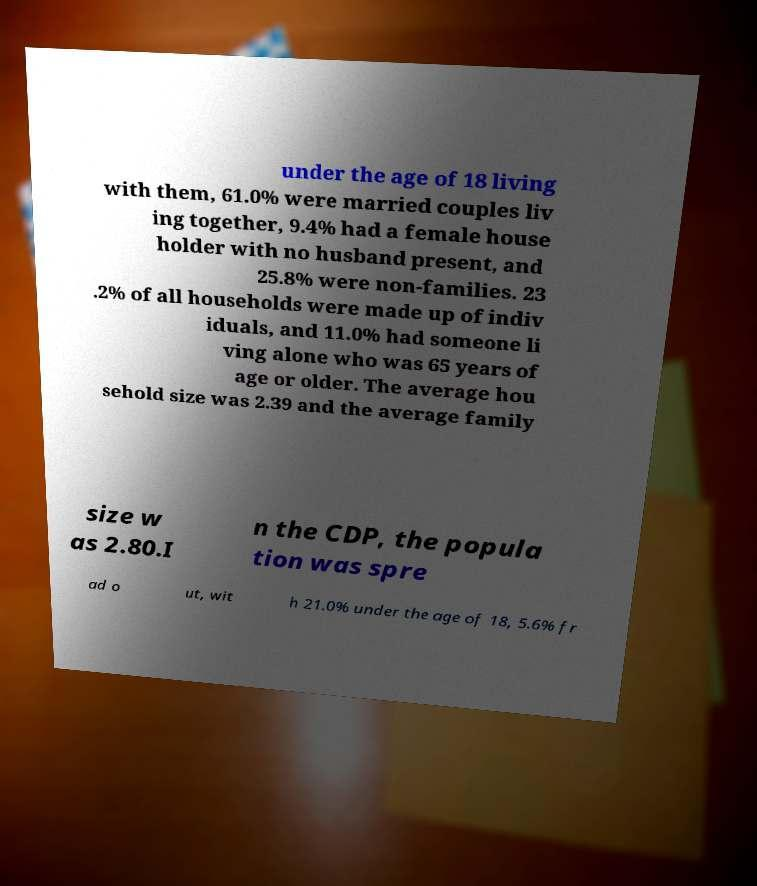There's text embedded in this image that I need extracted. Can you transcribe it verbatim? under the age of 18 living with them, 61.0% were married couples liv ing together, 9.4% had a female house holder with no husband present, and 25.8% were non-families. 23 .2% of all households were made up of indiv iduals, and 11.0% had someone li ving alone who was 65 years of age or older. The average hou sehold size was 2.39 and the average family size w as 2.80.I n the CDP, the popula tion was spre ad o ut, wit h 21.0% under the age of 18, 5.6% fr 